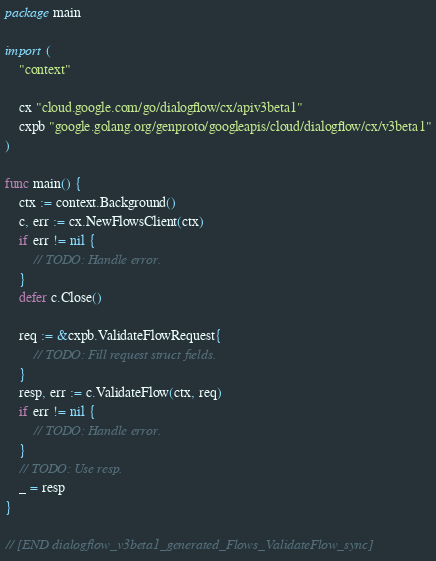<code> <loc_0><loc_0><loc_500><loc_500><_Go_>
package main

import (
	"context"

	cx "cloud.google.com/go/dialogflow/cx/apiv3beta1"
	cxpb "google.golang.org/genproto/googleapis/cloud/dialogflow/cx/v3beta1"
)

func main() {
	ctx := context.Background()
	c, err := cx.NewFlowsClient(ctx)
	if err != nil {
		// TODO: Handle error.
	}
	defer c.Close()

	req := &cxpb.ValidateFlowRequest{
		// TODO: Fill request struct fields.
	}
	resp, err := c.ValidateFlow(ctx, req)
	if err != nil {
		// TODO: Handle error.
	}
	// TODO: Use resp.
	_ = resp
}

// [END dialogflow_v3beta1_generated_Flows_ValidateFlow_sync]
</code> 